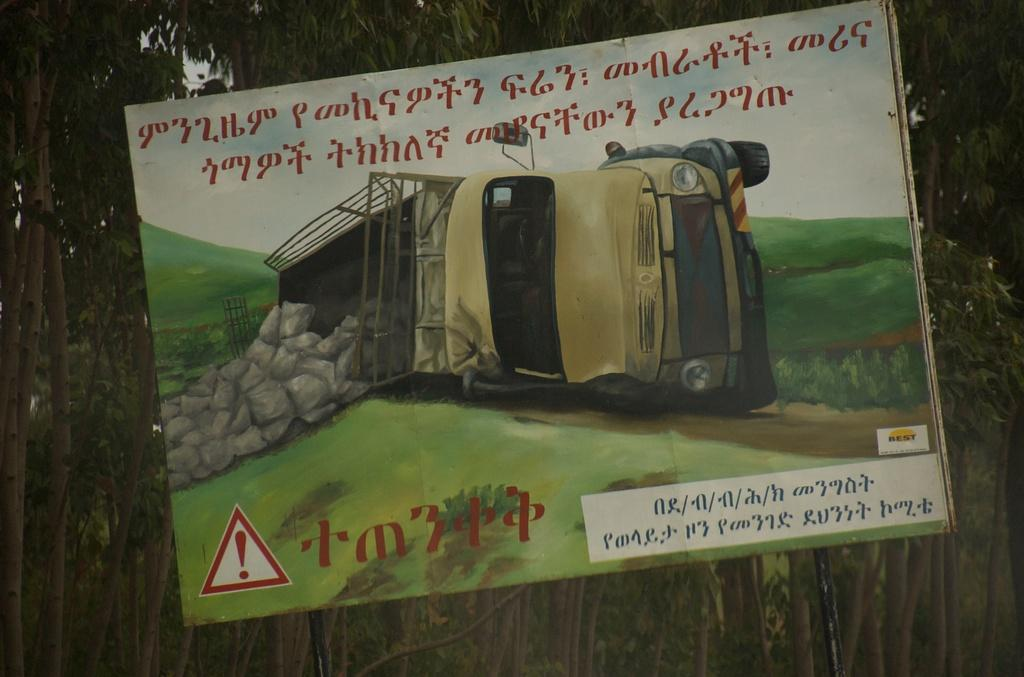What is the main object in the picture? There is a board in the picture. What is depicted on the board? The board has a painting of a vehicle. What can be seen in the sky in the picture? The sky is visible in the picture. What is written on the board? There is something written on the board. What is visible in the background of the picture? There are trees in the background of the picture. How many ants can be seen crawling on the board in the picture? There are no ants visible on the board in the picture. What color are the eyes of the vehicle depicted on the board? The vehicle in the painting does not have eyes, as it is not a living creature. 